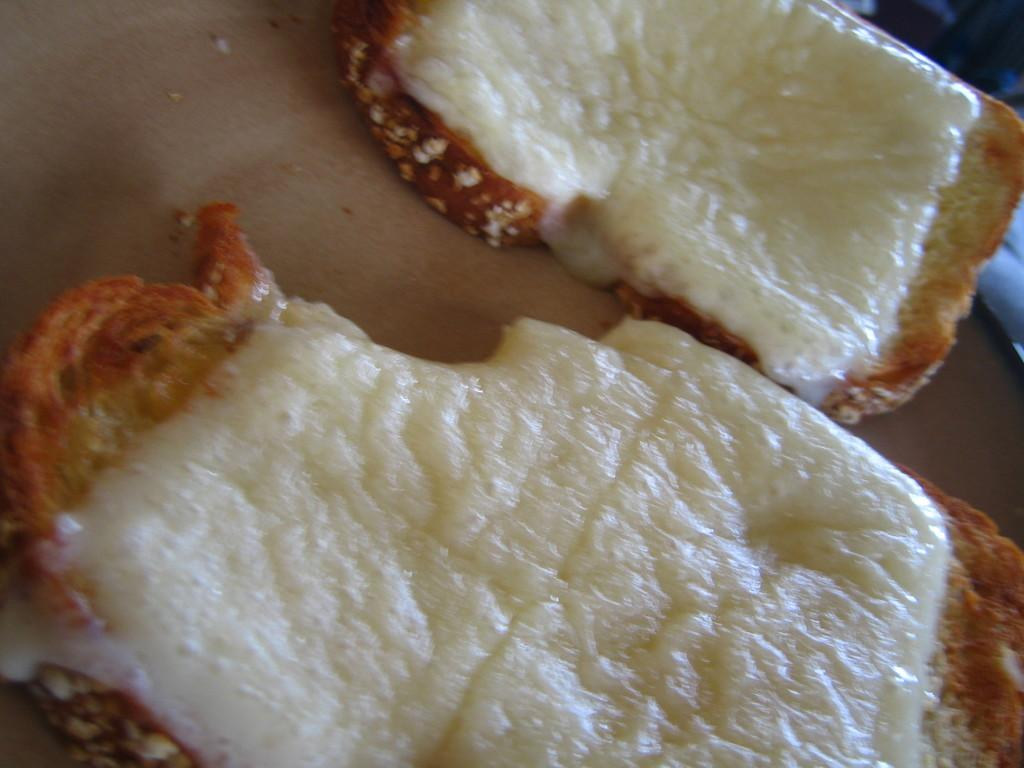What type of food can be seen in the image? There are slices of bread in the image. What is applied on the slices of bread? Cream is applied on the slices of bread. What guide is used to apply the cream on the slices of bread in the image? There is no guide visible in the image for applying the cream on the slices of bread. 